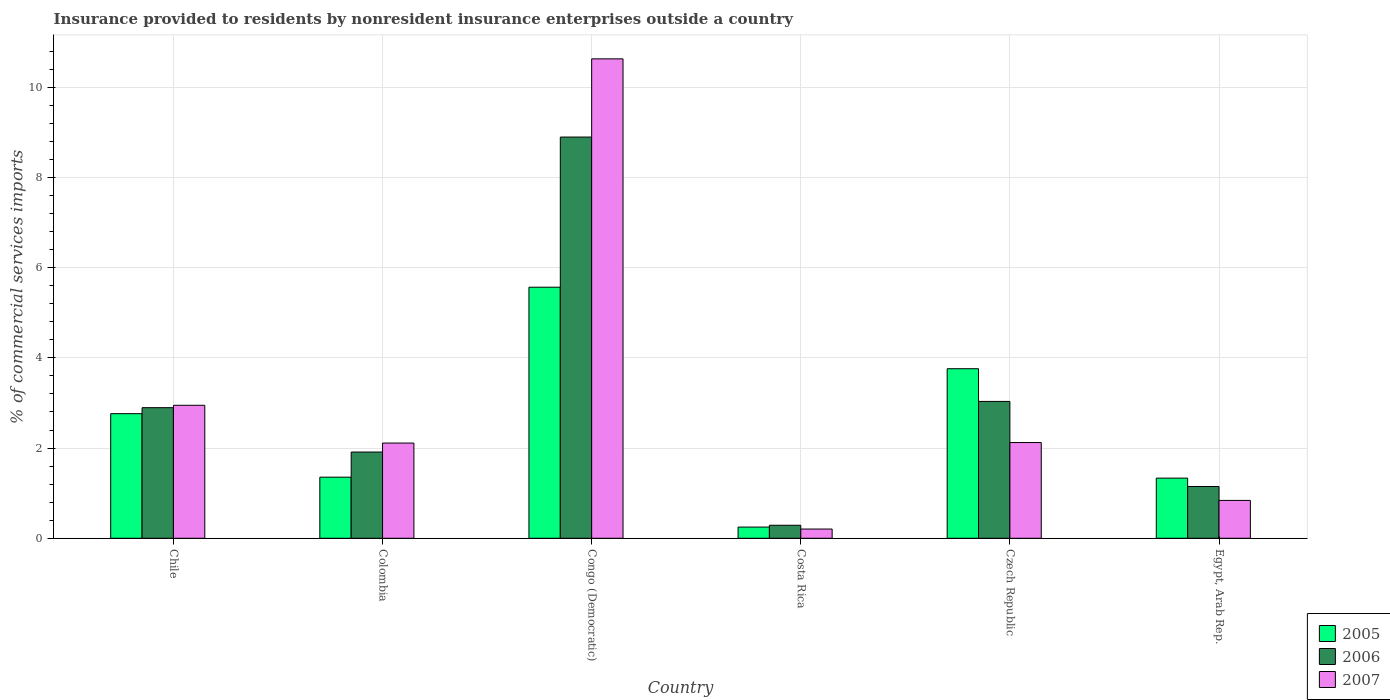How many different coloured bars are there?
Offer a very short reply. 3. How many groups of bars are there?
Ensure brevity in your answer.  6. Are the number of bars per tick equal to the number of legend labels?
Provide a short and direct response. Yes. Are the number of bars on each tick of the X-axis equal?
Provide a short and direct response. Yes. What is the label of the 6th group of bars from the left?
Provide a succinct answer. Egypt, Arab Rep. In how many cases, is the number of bars for a given country not equal to the number of legend labels?
Provide a short and direct response. 0. What is the Insurance provided to residents in 2005 in Congo (Democratic)?
Make the answer very short. 5.57. Across all countries, what is the maximum Insurance provided to residents in 2006?
Provide a short and direct response. 8.89. Across all countries, what is the minimum Insurance provided to residents in 2006?
Ensure brevity in your answer.  0.29. In which country was the Insurance provided to residents in 2007 maximum?
Your response must be concise. Congo (Democratic). What is the total Insurance provided to residents in 2007 in the graph?
Provide a succinct answer. 18.85. What is the difference between the Insurance provided to residents in 2006 in Chile and that in Congo (Democratic)?
Give a very brief answer. -6. What is the difference between the Insurance provided to residents in 2005 in Chile and the Insurance provided to residents in 2006 in Czech Republic?
Offer a very short reply. -0.27. What is the average Insurance provided to residents in 2007 per country?
Your response must be concise. 3.14. What is the difference between the Insurance provided to residents of/in 2007 and Insurance provided to residents of/in 2006 in Chile?
Ensure brevity in your answer.  0.05. What is the ratio of the Insurance provided to residents in 2005 in Costa Rica to that in Egypt, Arab Rep.?
Provide a short and direct response. 0.19. Is the Insurance provided to residents in 2006 in Colombia less than that in Costa Rica?
Ensure brevity in your answer.  No. Is the difference between the Insurance provided to residents in 2007 in Congo (Democratic) and Costa Rica greater than the difference between the Insurance provided to residents in 2006 in Congo (Democratic) and Costa Rica?
Your answer should be very brief. Yes. What is the difference between the highest and the second highest Insurance provided to residents in 2006?
Make the answer very short. 6. What is the difference between the highest and the lowest Insurance provided to residents in 2005?
Your response must be concise. 5.32. In how many countries, is the Insurance provided to residents in 2005 greater than the average Insurance provided to residents in 2005 taken over all countries?
Make the answer very short. 3. What does the 2nd bar from the left in Egypt, Arab Rep. represents?
Give a very brief answer. 2006. How many bars are there?
Your response must be concise. 18. Are all the bars in the graph horizontal?
Give a very brief answer. No. How many countries are there in the graph?
Provide a short and direct response. 6. What is the difference between two consecutive major ticks on the Y-axis?
Your answer should be very brief. 2. Does the graph contain any zero values?
Offer a terse response. No. Does the graph contain grids?
Make the answer very short. Yes. How many legend labels are there?
Offer a very short reply. 3. How are the legend labels stacked?
Provide a succinct answer. Vertical. What is the title of the graph?
Keep it short and to the point. Insurance provided to residents by nonresident insurance enterprises outside a country. What is the label or title of the X-axis?
Provide a short and direct response. Country. What is the label or title of the Y-axis?
Make the answer very short. % of commercial services imports. What is the % of commercial services imports of 2005 in Chile?
Keep it short and to the point. 2.76. What is the % of commercial services imports in 2006 in Chile?
Offer a terse response. 2.89. What is the % of commercial services imports in 2007 in Chile?
Make the answer very short. 2.95. What is the % of commercial services imports of 2005 in Colombia?
Your response must be concise. 1.35. What is the % of commercial services imports of 2006 in Colombia?
Your response must be concise. 1.91. What is the % of commercial services imports of 2007 in Colombia?
Make the answer very short. 2.11. What is the % of commercial services imports of 2005 in Congo (Democratic)?
Offer a very short reply. 5.57. What is the % of commercial services imports in 2006 in Congo (Democratic)?
Offer a very short reply. 8.89. What is the % of commercial services imports in 2007 in Congo (Democratic)?
Offer a very short reply. 10.63. What is the % of commercial services imports of 2005 in Costa Rica?
Provide a short and direct response. 0.25. What is the % of commercial services imports of 2006 in Costa Rica?
Give a very brief answer. 0.29. What is the % of commercial services imports in 2007 in Costa Rica?
Your answer should be compact. 0.2. What is the % of commercial services imports of 2005 in Czech Republic?
Your answer should be compact. 3.76. What is the % of commercial services imports of 2006 in Czech Republic?
Provide a short and direct response. 3.03. What is the % of commercial services imports in 2007 in Czech Republic?
Provide a succinct answer. 2.12. What is the % of commercial services imports in 2005 in Egypt, Arab Rep.?
Offer a very short reply. 1.33. What is the % of commercial services imports in 2006 in Egypt, Arab Rep.?
Provide a succinct answer. 1.15. What is the % of commercial services imports of 2007 in Egypt, Arab Rep.?
Offer a very short reply. 0.84. Across all countries, what is the maximum % of commercial services imports of 2005?
Your response must be concise. 5.57. Across all countries, what is the maximum % of commercial services imports in 2006?
Provide a short and direct response. 8.89. Across all countries, what is the maximum % of commercial services imports of 2007?
Provide a short and direct response. 10.63. Across all countries, what is the minimum % of commercial services imports of 2005?
Provide a succinct answer. 0.25. Across all countries, what is the minimum % of commercial services imports of 2006?
Offer a terse response. 0.29. Across all countries, what is the minimum % of commercial services imports of 2007?
Your answer should be compact. 0.2. What is the total % of commercial services imports of 2005 in the graph?
Your response must be concise. 15.02. What is the total % of commercial services imports in 2006 in the graph?
Your answer should be very brief. 18.17. What is the total % of commercial services imports in 2007 in the graph?
Offer a terse response. 18.85. What is the difference between the % of commercial services imports in 2005 in Chile and that in Colombia?
Give a very brief answer. 1.41. What is the difference between the % of commercial services imports of 2006 in Chile and that in Colombia?
Make the answer very short. 0.98. What is the difference between the % of commercial services imports of 2007 in Chile and that in Colombia?
Your answer should be very brief. 0.84. What is the difference between the % of commercial services imports in 2005 in Chile and that in Congo (Democratic)?
Offer a terse response. -2.8. What is the difference between the % of commercial services imports of 2006 in Chile and that in Congo (Democratic)?
Provide a short and direct response. -6. What is the difference between the % of commercial services imports of 2007 in Chile and that in Congo (Democratic)?
Ensure brevity in your answer.  -7.68. What is the difference between the % of commercial services imports of 2005 in Chile and that in Costa Rica?
Keep it short and to the point. 2.51. What is the difference between the % of commercial services imports of 2006 in Chile and that in Costa Rica?
Provide a short and direct response. 2.61. What is the difference between the % of commercial services imports in 2007 in Chile and that in Costa Rica?
Provide a succinct answer. 2.74. What is the difference between the % of commercial services imports in 2005 in Chile and that in Czech Republic?
Keep it short and to the point. -1. What is the difference between the % of commercial services imports of 2006 in Chile and that in Czech Republic?
Keep it short and to the point. -0.14. What is the difference between the % of commercial services imports of 2007 in Chile and that in Czech Republic?
Your answer should be very brief. 0.83. What is the difference between the % of commercial services imports in 2005 in Chile and that in Egypt, Arab Rep.?
Your answer should be compact. 1.43. What is the difference between the % of commercial services imports in 2006 in Chile and that in Egypt, Arab Rep.?
Make the answer very short. 1.75. What is the difference between the % of commercial services imports in 2007 in Chile and that in Egypt, Arab Rep.?
Provide a short and direct response. 2.11. What is the difference between the % of commercial services imports of 2005 in Colombia and that in Congo (Democratic)?
Give a very brief answer. -4.21. What is the difference between the % of commercial services imports in 2006 in Colombia and that in Congo (Democratic)?
Give a very brief answer. -6.98. What is the difference between the % of commercial services imports in 2007 in Colombia and that in Congo (Democratic)?
Ensure brevity in your answer.  -8.52. What is the difference between the % of commercial services imports of 2005 in Colombia and that in Costa Rica?
Provide a succinct answer. 1.11. What is the difference between the % of commercial services imports in 2006 in Colombia and that in Costa Rica?
Provide a short and direct response. 1.62. What is the difference between the % of commercial services imports of 2007 in Colombia and that in Costa Rica?
Make the answer very short. 1.91. What is the difference between the % of commercial services imports of 2005 in Colombia and that in Czech Republic?
Offer a terse response. -2.4. What is the difference between the % of commercial services imports of 2006 in Colombia and that in Czech Republic?
Your response must be concise. -1.12. What is the difference between the % of commercial services imports in 2007 in Colombia and that in Czech Republic?
Provide a succinct answer. -0.01. What is the difference between the % of commercial services imports in 2005 in Colombia and that in Egypt, Arab Rep.?
Give a very brief answer. 0.02. What is the difference between the % of commercial services imports in 2006 in Colombia and that in Egypt, Arab Rep.?
Provide a succinct answer. 0.76. What is the difference between the % of commercial services imports of 2007 in Colombia and that in Egypt, Arab Rep.?
Offer a very short reply. 1.27. What is the difference between the % of commercial services imports of 2005 in Congo (Democratic) and that in Costa Rica?
Make the answer very short. 5.32. What is the difference between the % of commercial services imports in 2006 in Congo (Democratic) and that in Costa Rica?
Your answer should be very brief. 8.6. What is the difference between the % of commercial services imports of 2007 in Congo (Democratic) and that in Costa Rica?
Your answer should be very brief. 10.42. What is the difference between the % of commercial services imports of 2005 in Congo (Democratic) and that in Czech Republic?
Your response must be concise. 1.81. What is the difference between the % of commercial services imports in 2006 in Congo (Democratic) and that in Czech Republic?
Your answer should be very brief. 5.86. What is the difference between the % of commercial services imports in 2007 in Congo (Democratic) and that in Czech Republic?
Your answer should be very brief. 8.51. What is the difference between the % of commercial services imports in 2005 in Congo (Democratic) and that in Egypt, Arab Rep.?
Provide a short and direct response. 4.23. What is the difference between the % of commercial services imports in 2006 in Congo (Democratic) and that in Egypt, Arab Rep.?
Offer a very short reply. 7.75. What is the difference between the % of commercial services imports of 2007 in Congo (Democratic) and that in Egypt, Arab Rep.?
Offer a terse response. 9.79. What is the difference between the % of commercial services imports in 2005 in Costa Rica and that in Czech Republic?
Provide a short and direct response. -3.51. What is the difference between the % of commercial services imports of 2006 in Costa Rica and that in Czech Republic?
Offer a terse response. -2.75. What is the difference between the % of commercial services imports of 2007 in Costa Rica and that in Czech Republic?
Provide a short and direct response. -1.92. What is the difference between the % of commercial services imports in 2005 in Costa Rica and that in Egypt, Arab Rep.?
Provide a succinct answer. -1.08. What is the difference between the % of commercial services imports in 2006 in Costa Rica and that in Egypt, Arab Rep.?
Keep it short and to the point. -0.86. What is the difference between the % of commercial services imports in 2007 in Costa Rica and that in Egypt, Arab Rep.?
Offer a very short reply. -0.63. What is the difference between the % of commercial services imports in 2005 in Czech Republic and that in Egypt, Arab Rep.?
Provide a succinct answer. 2.42. What is the difference between the % of commercial services imports in 2006 in Czech Republic and that in Egypt, Arab Rep.?
Provide a short and direct response. 1.89. What is the difference between the % of commercial services imports of 2007 in Czech Republic and that in Egypt, Arab Rep.?
Keep it short and to the point. 1.28. What is the difference between the % of commercial services imports of 2005 in Chile and the % of commercial services imports of 2006 in Colombia?
Offer a very short reply. 0.85. What is the difference between the % of commercial services imports in 2005 in Chile and the % of commercial services imports in 2007 in Colombia?
Ensure brevity in your answer.  0.65. What is the difference between the % of commercial services imports in 2006 in Chile and the % of commercial services imports in 2007 in Colombia?
Make the answer very short. 0.78. What is the difference between the % of commercial services imports of 2005 in Chile and the % of commercial services imports of 2006 in Congo (Democratic)?
Offer a terse response. -6.13. What is the difference between the % of commercial services imports in 2005 in Chile and the % of commercial services imports in 2007 in Congo (Democratic)?
Offer a very short reply. -7.87. What is the difference between the % of commercial services imports of 2006 in Chile and the % of commercial services imports of 2007 in Congo (Democratic)?
Provide a short and direct response. -7.73. What is the difference between the % of commercial services imports in 2005 in Chile and the % of commercial services imports in 2006 in Costa Rica?
Your answer should be compact. 2.47. What is the difference between the % of commercial services imports of 2005 in Chile and the % of commercial services imports of 2007 in Costa Rica?
Give a very brief answer. 2.56. What is the difference between the % of commercial services imports in 2006 in Chile and the % of commercial services imports in 2007 in Costa Rica?
Offer a very short reply. 2.69. What is the difference between the % of commercial services imports in 2005 in Chile and the % of commercial services imports in 2006 in Czech Republic?
Your response must be concise. -0.27. What is the difference between the % of commercial services imports of 2005 in Chile and the % of commercial services imports of 2007 in Czech Republic?
Provide a succinct answer. 0.64. What is the difference between the % of commercial services imports of 2006 in Chile and the % of commercial services imports of 2007 in Czech Republic?
Provide a succinct answer. 0.77. What is the difference between the % of commercial services imports in 2005 in Chile and the % of commercial services imports in 2006 in Egypt, Arab Rep.?
Ensure brevity in your answer.  1.61. What is the difference between the % of commercial services imports in 2005 in Chile and the % of commercial services imports in 2007 in Egypt, Arab Rep.?
Give a very brief answer. 1.92. What is the difference between the % of commercial services imports of 2006 in Chile and the % of commercial services imports of 2007 in Egypt, Arab Rep.?
Give a very brief answer. 2.06. What is the difference between the % of commercial services imports in 2005 in Colombia and the % of commercial services imports in 2006 in Congo (Democratic)?
Offer a very short reply. -7.54. What is the difference between the % of commercial services imports in 2005 in Colombia and the % of commercial services imports in 2007 in Congo (Democratic)?
Give a very brief answer. -9.27. What is the difference between the % of commercial services imports of 2006 in Colombia and the % of commercial services imports of 2007 in Congo (Democratic)?
Your answer should be very brief. -8.72. What is the difference between the % of commercial services imports of 2005 in Colombia and the % of commercial services imports of 2006 in Costa Rica?
Your response must be concise. 1.07. What is the difference between the % of commercial services imports of 2005 in Colombia and the % of commercial services imports of 2007 in Costa Rica?
Provide a short and direct response. 1.15. What is the difference between the % of commercial services imports of 2006 in Colombia and the % of commercial services imports of 2007 in Costa Rica?
Offer a terse response. 1.71. What is the difference between the % of commercial services imports of 2005 in Colombia and the % of commercial services imports of 2006 in Czech Republic?
Offer a very short reply. -1.68. What is the difference between the % of commercial services imports in 2005 in Colombia and the % of commercial services imports in 2007 in Czech Republic?
Your answer should be compact. -0.77. What is the difference between the % of commercial services imports in 2006 in Colombia and the % of commercial services imports in 2007 in Czech Republic?
Provide a short and direct response. -0.21. What is the difference between the % of commercial services imports of 2005 in Colombia and the % of commercial services imports of 2006 in Egypt, Arab Rep.?
Keep it short and to the point. 0.21. What is the difference between the % of commercial services imports of 2005 in Colombia and the % of commercial services imports of 2007 in Egypt, Arab Rep.?
Ensure brevity in your answer.  0.52. What is the difference between the % of commercial services imports of 2006 in Colombia and the % of commercial services imports of 2007 in Egypt, Arab Rep.?
Give a very brief answer. 1.07. What is the difference between the % of commercial services imports in 2005 in Congo (Democratic) and the % of commercial services imports in 2006 in Costa Rica?
Offer a terse response. 5.28. What is the difference between the % of commercial services imports in 2005 in Congo (Democratic) and the % of commercial services imports in 2007 in Costa Rica?
Your response must be concise. 5.36. What is the difference between the % of commercial services imports in 2006 in Congo (Democratic) and the % of commercial services imports in 2007 in Costa Rica?
Your answer should be compact. 8.69. What is the difference between the % of commercial services imports in 2005 in Congo (Democratic) and the % of commercial services imports in 2006 in Czech Republic?
Give a very brief answer. 2.53. What is the difference between the % of commercial services imports of 2005 in Congo (Democratic) and the % of commercial services imports of 2007 in Czech Republic?
Keep it short and to the point. 3.44. What is the difference between the % of commercial services imports of 2006 in Congo (Democratic) and the % of commercial services imports of 2007 in Czech Republic?
Offer a terse response. 6.77. What is the difference between the % of commercial services imports in 2005 in Congo (Democratic) and the % of commercial services imports in 2006 in Egypt, Arab Rep.?
Your answer should be compact. 4.42. What is the difference between the % of commercial services imports in 2005 in Congo (Democratic) and the % of commercial services imports in 2007 in Egypt, Arab Rep.?
Your answer should be compact. 4.73. What is the difference between the % of commercial services imports in 2006 in Congo (Democratic) and the % of commercial services imports in 2007 in Egypt, Arab Rep.?
Offer a terse response. 8.05. What is the difference between the % of commercial services imports of 2005 in Costa Rica and the % of commercial services imports of 2006 in Czech Republic?
Give a very brief answer. -2.79. What is the difference between the % of commercial services imports in 2005 in Costa Rica and the % of commercial services imports in 2007 in Czech Republic?
Your answer should be compact. -1.87. What is the difference between the % of commercial services imports in 2006 in Costa Rica and the % of commercial services imports in 2007 in Czech Republic?
Your answer should be compact. -1.83. What is the difference between the % of commercial services imports of 2005 in Costa Rica and the % of commercial services imports of 2006 in Egypt, Arab Rep.?
Keep it short and to the point. -0.9. What is the difference between the % of commercial services imports in 2005 in Costa Rica and the % of commercial services imports in 2007 in Egypt, Arab Rep.?
Offer a very short reply. -0.59. What is the difference between the % of commercial services imports in 2006 in Costa Rica and the % of commercial services imports in 2007 in Egypt, Arab Rep.?
Make the answer very short. -0.55. What is the difference between the % of commercial services imports of 2005 in Czech Republic and the % of commercial services imports of 2006 in Egypt, Arab Rep.?
Ensure brevity in your answer.  2.61. What is the difference between the % of commercial services imports in 2005 in Czech Republic and the % of commercial services imports in 2007 in Egypt, Arab Rep.?
Your response must be concise. 2.92. What is the difference between the % of commercial services imports in 2006 in Czech Republic and the % of commercial services imports in 2007 in Egypt, Arab Rep.?
Provide a short and direct response. 2.19. What is the average % of commercial services imports in 2005 per country?
Make the answer very short. 2.5. What is the average % of commercial services imports in 2006 per country?
Ensure brevity in your answer.  3.03. What is the average % of commercial services imports in 2007 per country?
Offer a very short reply. 3.14. What is the difference between the % of commercial services imports of 2005 and % of commercial services imports of 2006 in Chile?
Your answer should be compact. -0.13. What is the difference between the % of commercial services imports of 2005 and % of commercial services imports of 2007 in Chile?
Make the answer very short. -0.19. What is the difference between the % of commercial services imports of 2006 and % of commercial services imports of 2007 in Chile?
Your answer should be very brief. -0.05. What is the difference between the % of commercial services imports of 2005 and % of commercial services imports of 2006 in Colombia?
Make the answer very short. -0.56. What is the difference between the % of commercial services imports in 2005 and % of commercial services imports in 2007 in Colombia?
Your response must be concise. -0.76. What is the difference between the % of commercial services imports of 2006 and % of commercial services imports of 2007 in Colombia?
Your response must be concise. -0.2. What is the difference between the % of commercial services imports in 2005 and % of commercial services imports in 2006 in Congo (Democratic)?
Your response must be concise. -3.33. What is the difference between the % of commercial services imports of 2005 and % of commercial services imports of 2007 in Congo (Democratic)?
Give a very brief answer. -5.06. What is the difference between the % of commercial services imports of 2006 and % of commercial services imports of 2007 in Congo (Democratic)?
Offer a very short reply. -1.73. What is the difference between the % of commercial services imports of 2005 and % of commercial services imports of 2006 in Costa Rica?
Make the answer very short. -0.04. What is the difference between the % of commercial services imports in 2005 and % of commercial services imports in 2007 in Costa Rica?
Make the answer very short. 0.04. What is the difference between the % of commercial services imports in 2006 and % of commercial services imports in 2007 in Costa Rica?
Your answer should be compact. 0.08. What is the difference between the % of commercial services imports of 2005 and % of commercial services imports of 2006 in Czech Republic?
Your response must be concise. 0.72. What is the difference between the % of commercial services imports of 2005 and % of commercial services imports of 2007 in Czech Republic?
Ensure brevity in your answer.  1.64. What is the difference between the % of commercial services imports in 2006 and % of commercial services imports in 2007 in Czech Republic?
Your response must be concise. 0.91. What is the difference between the % of commercial services imports of 2005 and % of commercial services imports of 2006 in Egypt, Arab Rep.?
Ensure brevity in your answer.  0.19. What is the difference between the % of commercial services imports in 2005 and % of commercial services imports in 2007 in Egypt, Arab Rep.?
Offer a very short reply. 0.49. What is the difference between the % of commercial services imports of 2006 and % of commercial services imports of 2007 in Egypt, Arab Rep.?
Your answer should be very brief. 0.31. What is the ratio of the % of commercial services imports in 2005 in Chile to that in Colombia?
Your answer should be very brief. 2.04. What is the ratio of the % of commercial services imports of 2006 in Chile to that in Colombia?
Offer a very short reply. 1.51. What is the ratio of the % of commercial services imports in 2007 in Chile to that in Colombia?
Offer a terse response. 1.4. What is the ratio of the % of commercial services imports of 2005 in Chile to that in Congo (Democratic)?
Give a very brief answer. 0.5. What is the ratio of the % of commercial services imports of 2006 in Chile to that in Congo (Democratic)?
Your answer should be compact. 0.33. What is the ratio of the % of commercial services imports in 2007 in Chile to that in Congo (Democratic)?
Provide a short and direct response. 0.28. What is the ratio of the % of commercial services imports of 2005 in Chile to that in Costa Rica?
Your answer should be compact. 11.12. What is the ratio of the % of commercial services imports of 2006 in Chile to that in Costa Rica?
Offer a terse response. 10.03. What is the ratio of the % of commercial services imports in 2007 in Chile to that in Costa Rica?
Provide a short and direct response. 14.39. What is the ratio of the % of commercial services imports in 2005 in Chile to that in Czech Republic?
Provide a succinct answer. 0.73. What is the ratio of the % of commercial services imports of 2006 in Chile to that in Czech Republic?
Your response must be concise. 0.95. What is the ratio of the % of commercial services imports of 2007 in Chile to that in Czech Republic?
Your answer should be compact. 1.39. What is the ratio of the % of commercial services imports in 2005 in Chile to that in Egypt, Arab Rep.?
Make the answer very short. 2.07. What is the ratio of the % of commercial services imports of 2006 in Chile to that in Egypt, Arab Rep.?
Give a very brief answer. 2.52. What is the ratio of the % of commercial services imports in 2007 in Chile to that in Egypt, Arab Rep.?
Your answer should be very brief. 3.51. What is the ratio of the % of commercial services imports of 2005 in Colombia to that in Congo (Democratic)?
Keep it short and to the point. 0.24. What is the ratio of the % of commercial services imports of 2006 in Colombia to that in Congo (Democratic)?
Your response must be concise. 0.21. What is the ratio of the % of commercial services imports of 2007 in Colombia to that in Congo (Democratic)?
Make the answer very short. 0.2. What is the ratio of the % of commercial services imports in 2005 in Colombia to that in Costa Rica?
Ensure brevity in your answer.  5.45. What is the ratio of the % of commercial services imports in 2006 in Colombia to that in Costa Rica?
Provide a succinct answer. 6.62. What is the ratio of the % of commercial services imports of 2007 in Colombia to that in Costa Rica?
Your answer should be very brief. 10.3. What is the ratio of the % of commercial services imports of 2005 in Colombia to that in Czech Republic?
Offer a very short reply. 0.36. What is the ratio of the % of commercial services imports of 2006 in Colombia to that in Czech Republic?
Your response must be concise. 0.63. What is the ratio of the % of commercial services imports of 2007 in Colombia to that in Czech Republic?
Ensure brevity in your answer.  0.99. What is the ratio of the % of commercial services imports in 2006 in Colombia to that in Egypt, Arab Rep.?
Provide a short and direct response. 1.67. What is the ratio of the % of commercial services imports of 2007 in Colombia to that in Egypt, Arab Rep.?
Offer a very short reply. 2.51. What is the ratio of the % of commercial services imports of 2005 in Congo (Democratic) to that in Costa Rica?
Offer a very short reply. 22.41. What is the ratio of the % of commercial services imports in 2006 in Congo (Democratic) to that in Costa Rica?
Ensure brevity in your answer.  30.8. What is the ratio of the % of commercial services imports of 2007 in Congo (Democratic) to that in Costa Rica?
Provide a succinct answer. 51.87. What is the ratio of the % of commercial services imports in 2005 in Congo (Democratic) to that in Czech Republic?
Provide a short and direct response. 1.48. What is the ratio of the % of commercial services imports of 2006 in Congo (Democratic) to that in Czech Republic?
Keep it short and to the point. 2.93. What is the ratio of the % of commercial services imports in 2007 in Congo (Democratic) to that in Czech Republic?
Offer a terse response. 5.01. What is the ratio of the % of commercial services imports in 2005 in Congo (Democratic) to that in Egypt, Arab Rep.?
Your response must be concise. 4.17. What is the ratio of the % of commercial services imports in 2006 in Congo (Democratic) to that in Egypt, Arab Rep.?
Give a very brief answer. 7.75. What is the ratio of the % of commercial services imports of 2007 in Congo (Democratic) to that in Egypt, Arab Rep.?
Offer a terse response. 12.66. What is the ratio of the % of commercial services imports in 2005 in Costa Rica to that in Czech Republic?
Provide a short and direct response. 0.07. What is the ratio of the % of commercial services imports in 2006 in Costa Rica to that in Czech Republic?
Your answer should be very brief. 0.1. What is the ratio of the % of commercial services imports of 2007 in Costa Rica to that in Czech Republic?
Give a very brief answer. 0.1. What is the ratio of the % of commercial services imports of 2005 in Costa Rica to that in Egypt, Arab Rep.?
Your answer should be very brief. 0.19. What is the ratio of the % of commercial services imports of 2006 in Costa Rica to that in Egypt, Arab Rep.?
Your response must be concise. 0.25. What is the ratio of the % of commercial services imports in 2007 in Costa Rica to that in Egypt, Arab Rep.?
Provide a succinct answer. 0.24. What is the ratio of the % of commercial services imports in 2005 in Czech Republic to that in Egypt, Arab Rep.?
Your answer should be compact. 2.82. What is the ratio of the % of commercial services imports in 2006 in Czech Republic to that in Egypt, Arab Rep.?
Your answer should be very brief. 2.64. What is the ratio of the % of commercial services imports of 2007 in Czech Republic to that in Egypt, Arab Rep.?
Offer a very short reply. 2.53. What is the difference between the highest and the second highest % of commercial services imports in 2005?
Keep it short and to the point. 1.81. What is the difference between the highest and the second highest % of commercial services imports in 2006?
Provide a short and direct response. 5.86. What is the difference between the highest and the second highest % of commercial services imports of 2007?
Offer a very short reply. 7.68. What is the difference between the highest and the lowest % of commercial services imports in 2005?
Keep it short and to the point. 5.32. What is the difference between the highest and the lowest % of commercial services imports of 2006?
Keep it short and to the point. 8.6. What is the difference between the highest and the lowest % of commercial services imports in 2007?
Your answer should be very brief. 10.42. 